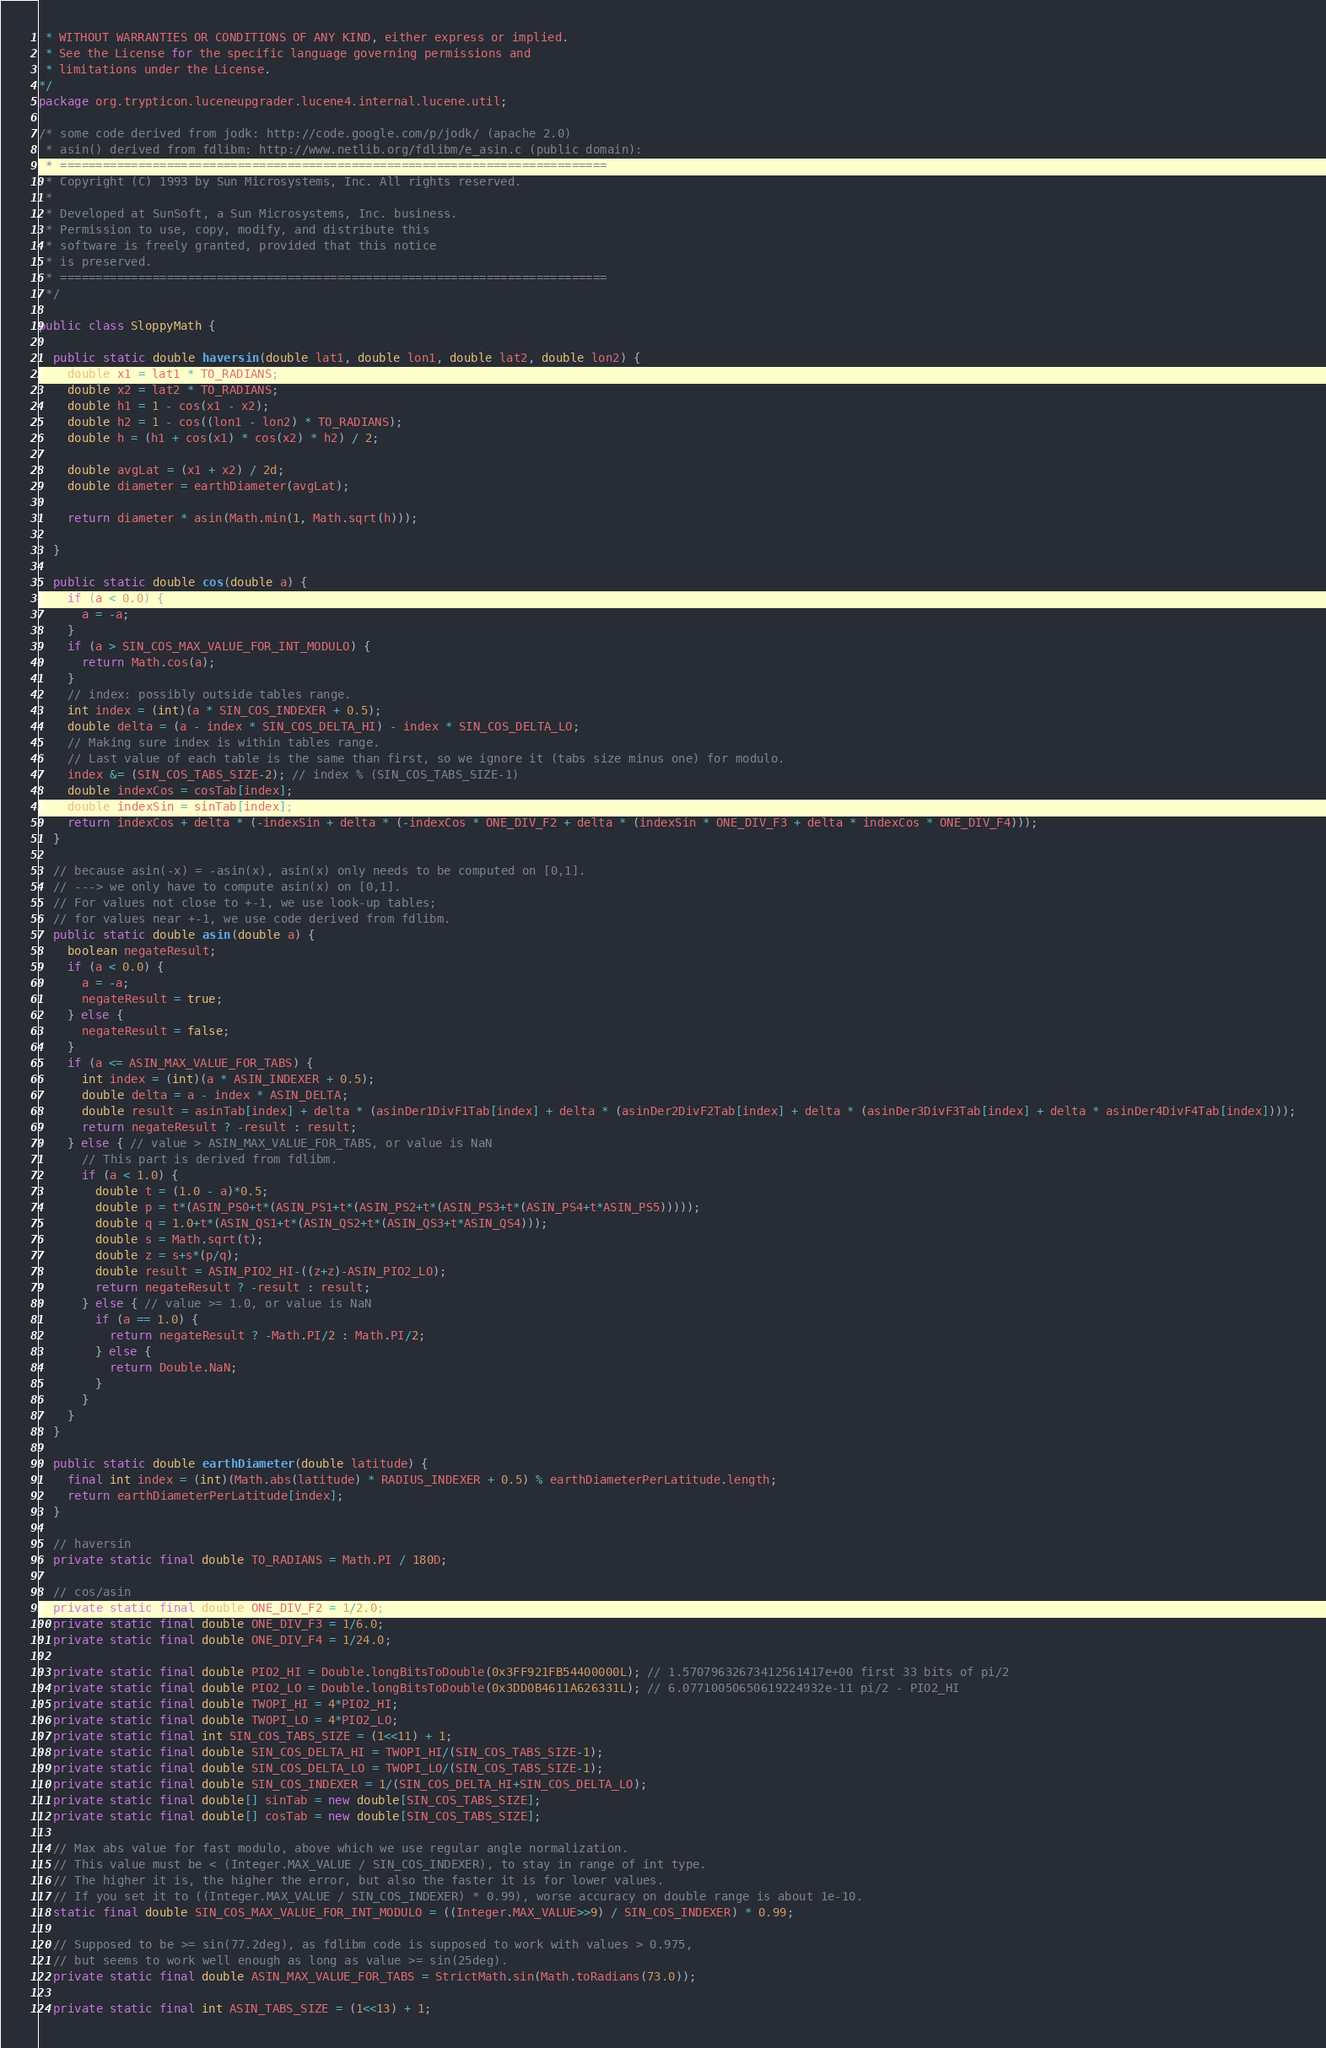Convert code to text. <code><loc_0><loc_0><loc_500><loc_500><_Java_> * WITHOUT WARRANTIES OR CONDITIONS OF ANY KIND, either express or implied.
 * See the License for the specific language governing permissions and
 * limitations under the License.
*/
package org.trypticon.luceneupgrader.lucene4.internal.lucene.util;

/* some code derived from jodk: http://code.google.com/p/jodk/ (apache 2.0)
 * asin() derived from fdlibm: http://www.netlib.org/fdlibm/e_asin.c (public domain):
 * =============================================================================
 * Copyright (C) 1993 by Sun Microsystems, Inc. All rights reserved.
 *
 * Developed at SunSoft, a Sun Microsystems, Inc. business.
 * Permission to use, copy, modify, and distribute this
 * software is freely granted, provided that this notice 
 * is preserved.
 * =============================================================================
 */

public class SloppyMath {
  
  public static double haversin(double lat1, double lon1, double lat2, double lon2) {
    double x1 = lat1 * TO_RADIANS;
    double x2 = lat2 * TO_RADIANS;
    double h1 = 1 - cos(x1 - x2);
    double h2 = 1 - cos((lon1 - lon2) * TO_RADIANS);
    double h = (h1 + cos(x1) * cos(x2) * h2) / 2;

    double avgLat = (x1 + x2) / 2d;
    double diameter = earthDiameter(avgLat);

    return diameter * asin(Math.min(1, Math.sqrt(h)));
    
  }

  public static double cos(double a) {
    if (a < 0.0) {
      a = -a;
    }
    if (a > SIN_COS_MAX_VALUE_FOR_INT_MODULO) {
      return Math.cos(a);
    }
    // index: possibly outside tables range.
    int index = (int)(a * SIN_COS_INDEXER + 0.5);
    double delta = (a - index * SIN_COS_DELTA_HI) - index * SIN_COS_DELTA_LO;
    // Making sure index is within tables range.
    // Last value of each table is the same than first, so we ignore it (tabs size minus one) for modulo.
    index &= (SIN_COS_TABS_SIZE-2); // index % (SIN_COS_TABS_SIZE-1)
    double indexCos = cosTab[index];
    double indexSin = sinTab[index];
    return indexCos + delta * (-indexSin + delta * (-indexCos * ONE_DIV_F2 + delta * (indexSin * ONE_DIV_F3 + delta * indexCos * ONE_DIV_F4)));
  }
  
  // because asin(-x) = -asin(x), asin(x) only needs to be computed on [0,1].
  // ---> we only have to compute asin(x) on [0,1].
  // For values not close to +-1, we use look-up tables;
  // for values near +-1, we use code derived from fdlibm.
  public static double asin(double a) { 
    boolean negateResult;
    if (a < 0.0) {
      a = -a;
      negateResult = true;
    } else {
      negateResult = false;
    }
    if (a <= ASIN_MAX_VALUE_FOR_TABS) {
      int index = (int)(a * ASIN_INDEXER + 0.5);
      double delta = a - index * ASIN_DELTA;
      double result = asinTab[index] + delta * (asinDer1DivF1Tab[index] + delta * (asinDer2DivF2Tab[index] + delta * (asinDer3DivF3Tab[index] + delta * asinDer4DivF4Tab[index])));
      return negateResult ? -result : result;
    } else { // value > ASIN_MAX_VALUE_FOR_TABS, or value is NaN
      // This part is derived from fdlibm.
      if (a < 1.0) {
        double t = (1.0 - a)*0.5;
        double p = t*(ASIN_PS0+t*(ASIN_PS1+t*(ASIN_PS2+t*(ASIN_PS3+t*(ASIN_PS4+t*ASIN_PS5)))));
        double q = 1.0+t*(ASIN_QS1+t*(ASIN_QS2+t*(ASIN_QS3+t*ASIN_QS4)));
        double s = Math.sqrt(t);
        double z = s+s*(p/q);
        double result = ASIN_PIO2_HI-((z+z)-ASIN_PIO2_LO);
        return negateResult ? -result : result;
      } else { // value >= 1.0, or value is NaN
        if (a == 1.0) {
          return negateResult ? -Math.PI/2 : Math.PI/2;
        } else {
          return Double.NaN;
        }
      }
    }
  }

  public static double earthDiameter(double latitude) {
    final int index = (int)(Math.abs(latitude) * RADIUS_INDEXER + 0.5) % earthDiameterPerLatitude.length;
    return earthDiameterPerLatitude[index];
  }

  // haversin
  private static final double TO_RADIANS = Math.PI / 180D;
  
  // cos/asin
  private static final double ONE_DIV_F2 = 1/2.0;
  private static final double ONE_DIV_F3 = 1/6.0;
  private static final double ONE_DIV_F4 = 1/24.0;
  
  private static final double PIO2_HI = Double.longBitsToDouble(0x3FF921FB54400000L); // 1.57079632673412561417e+00 first 33 bits of pi/2
  private static final double PIO2_LO = Double.longBitsToDouble(0x3DD0B4611A626331L); // 6.07710050650619224932e-11 pi/2 - PIO2_HI
  private static final double TWOPI_HI = 4*PIO2_HI;
  private static final double TWOPI_LO = 4*PIO2_LO;
  private static final int SIN_COS_TABS_SIZE = (1<<11) + 1;
  private static final double SIN_COS_DELTA_HI = TWOPI_HI/(SIN_COS_TABS_SIZE-1);
  private static final double SIN_COS_DELTA_LO = TWOPI_LO/(SIN_COS_TABS_SIZE-1);
  private static final double SIN_COS_INDEXER = 1/(SIN_COS_DELTA_HI+SIN_COS_DELTA_LO);
  private static final double[] sinTab = new double[SIN_COS_TABS_SIZE];
  private static final double[] cosTab = new double[SIN_COS_TABS_SIZE];
  
  // Max abs value for fast modulo, above which we use regular angle normalization.
  // This value must be < (Integer.MAX_VALUE / SIN_COS_INDEXER), to stay in range of int type.
  // The higher it is, the higher the error, but also the faster it is for lower values.
  // If you set it to ((Integer.MAX_VALUE / SIN_COS_INDEXER) * 0.99), worse accuracy on double range is about 1e-10.
  static final double SIN_COS_MAX_VALUE_FOR_INT_MODULO = ((Integer.MAX_VALUE>>9) / SIN_COS_INDEXER) * 0.99;
    
  // Supposed to be >= sin(77.2deg), as fdlibm code is supposed to work with values > 0.975,
  // but seems to work well enough as long as value >= sin(25deg).
  private static final double ASIN_MAX_VALUE_FOR_TABS = StrictMath.sin(Math.toRadians(73.0));
  
  private static final int ASIN_TABS_SIZE = (1<<13) + 1;</code> 